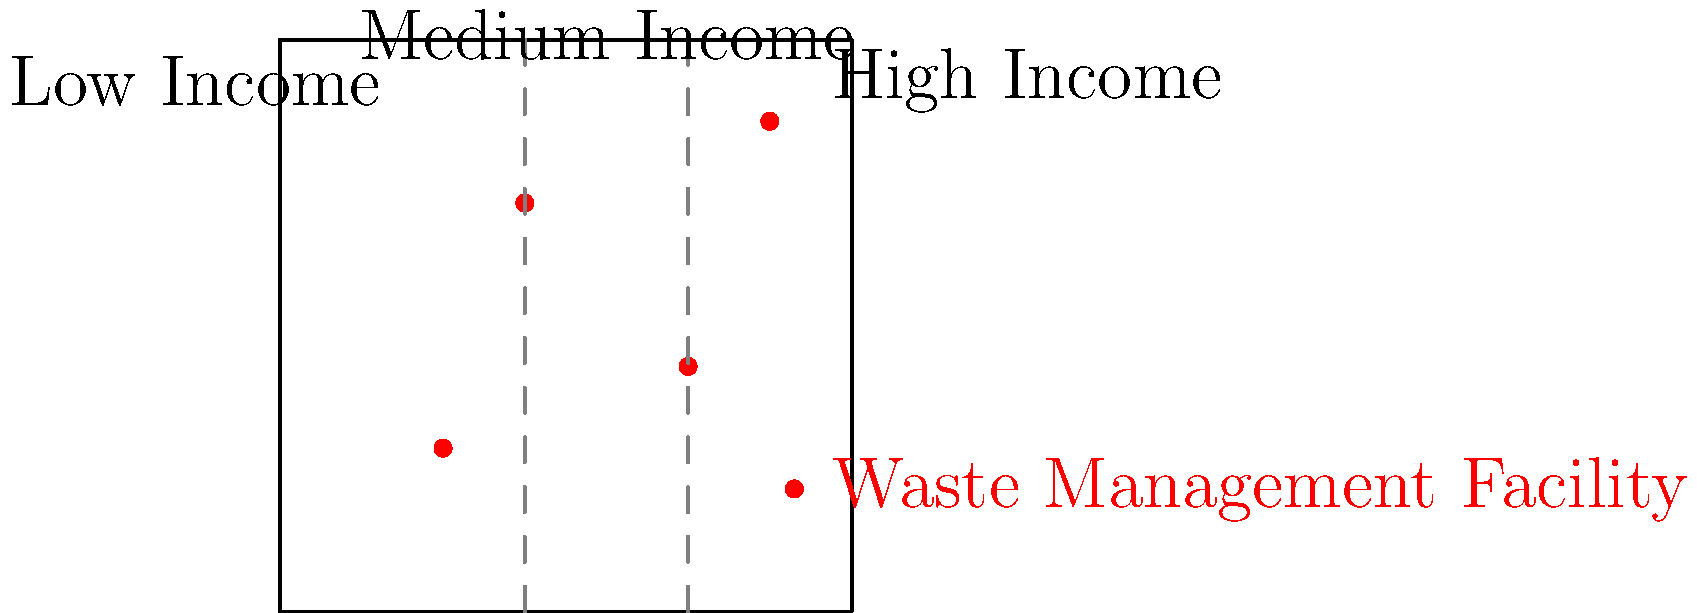Based on the map showing waste management facility locations and income level distributions in a city, what environmental justice concern can be identified? To answer this question, we need to analyze the distribution of waste management facilities in relation to income levels across the city. Let's break it down step-by-step:

1. Observe the map layout:
   - The city is divided into three income level areas: low, medium, and high.
   - Waste management facilities are represented by red dots.

2. Count the number of facilities in each income level area:
   - Low Income (left section): 1 facility
   - Medium Income (middle section): 2 facilities
   - High Income (right section): 1 facility

3. Analyze the distribution:
   - There are more facilities in the low and medium income areas combined (3) compared to the high income area (1).
   - The medium income area has the highest concentration of facilities.

4. Consider environmental justice principles:
   - Environmental justice aims to ensure fair treatment and meaningful involvement of all people regardless of race, color, national origin, or income with respect to environmental regulations and policies.
   - The unequal distribution of waste management facilities across income levels may indicate an environmental justice concern.

5. Identify the specific concern:
   - Lower and medium income areas bear a disproportionate burden of waste management facilities.
   - This distribution may lead to increased exposure to potential environmental hazards for residents in these areas.

The environmental justice concern identified from this map is the disproportionate concentration of waste management facilities in lower and medium income areas, potentially exposing these communities to greater environmental risks compared to high income areas.
Answer: Disproportionate burden on lower and medium income areas 